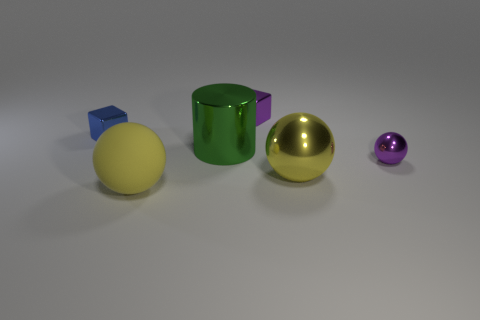Does the cylinder have the same material as the small purple thing behind the small ball?
Make the answer very short. Yes. Is there anything else that is the same shape as the blue thing?
Make the answer very short. Yes. Does the small purple ball have the same material as the green object?
Keep it short and to the point. Yes. There is a yellow matte sphere to the left of the purple block; is there a big green metallic thing in front of it?
Keep it short and to the point. No. How many tiny things are behind the blue object and in front of the purple metal block?
Provide a succinct answer. 0. The small purple object right of the big yellow metallic thing has what shape?
Give a very brief answer. Sphere. What number of yellow balls are the same size as the blue shiny thing?
Offer a terse response. 0. There is a large shiny thing that is behind the small sphere; does it have the same color as the rubber sphere?
Offer a terse response. No. What is the thing that is in front of the purple metallic sphere and on the right side of the big metal cylinder made of?
Make the answer very short. Metal. Is the number of big green balls greater than the number of yellow metallic objects?
Your answer should be very brief. No. 